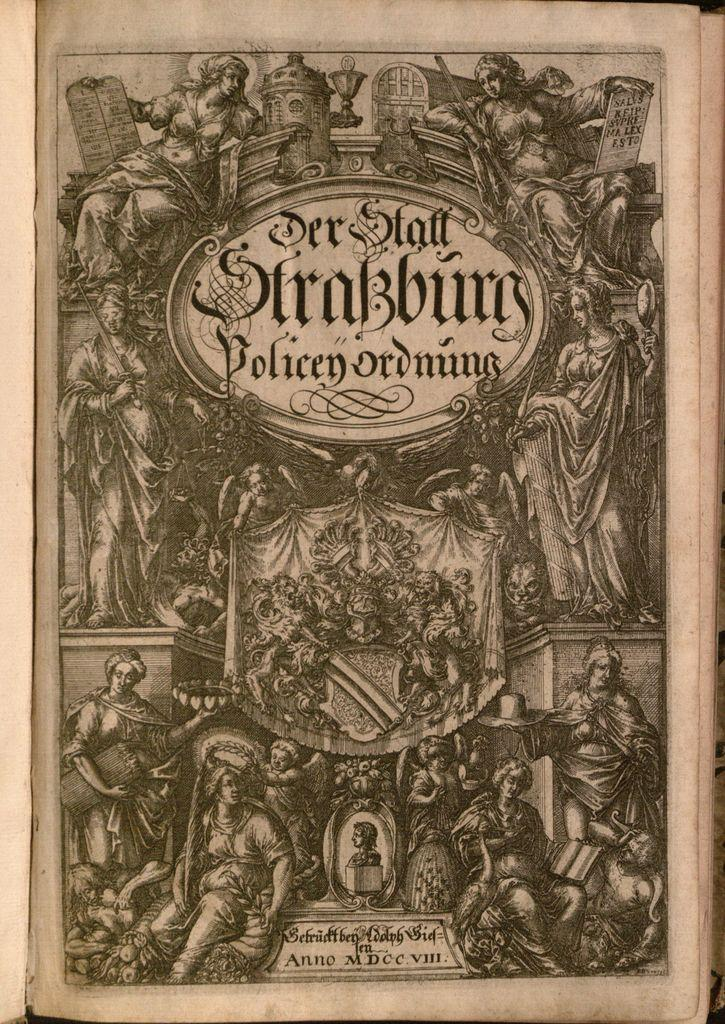<image>
Create a compact narrative representing the image presented. An old text with the title of a work of art called Der Staff Strassburg. 